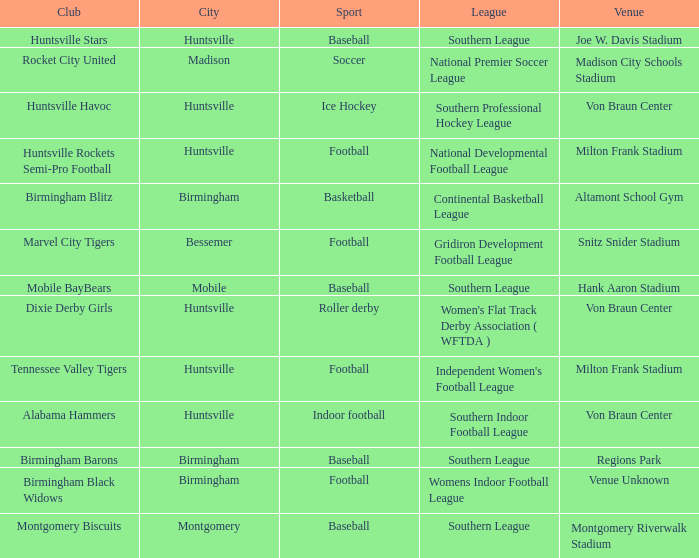Which venue hosted the Dixie Derby Girls? Von Braun Center. 